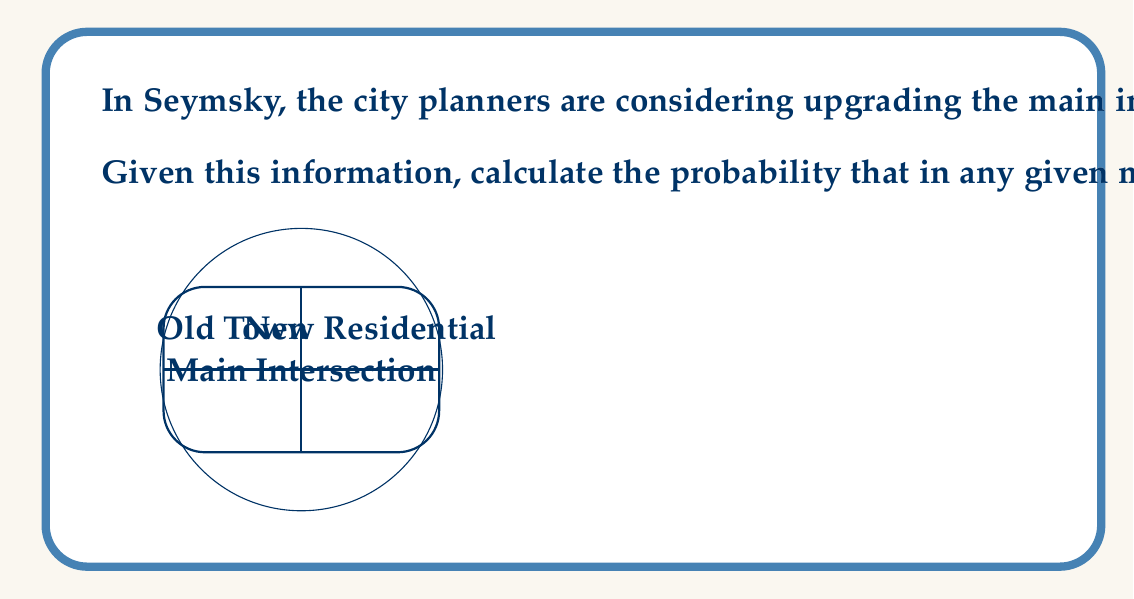Can you solve this math problem? Let's approach this step-by-step:

1) The number of cars arriving follows a Poisson distribution with mean $\lambda = 30$ cars per minute.

2) The intersection capacity is 25 cars per minute.

3) We need to find $P(X > 25)$, where $X$ is the number of arriving cars per minute.

4) For a Poisson distribution, $P(X > k) = 1 - P(X \leq k)$

5) Therefore, we need to calculate $1 - P(X \leq 25)$

6) The cumulative probability function for a Poisson distribution is:

   $$P(X \leq k) = e^{-\lambda} \sum_{i=0}^k \frac{\lambda^i}{i!}$$

7) Plugging in our values:

   $$P(X \leq 25) = e^{-30} \sum_{i=0}^{25} \frac{30^i}{i!}$$

8) This sum is difficult to calculate by hand, so we would typically use software or statistical tables. Using a calculator or computer, we get:

   $$P(X \leq 25) \approx 0.1954$$

9) Therefore, $P(X > 25) = 1 - P(X \leq 25) = 1 - 0.1954 = 0.8046$

10) Rounding to four decimal places: 0.8046
Answer: 0.8046 